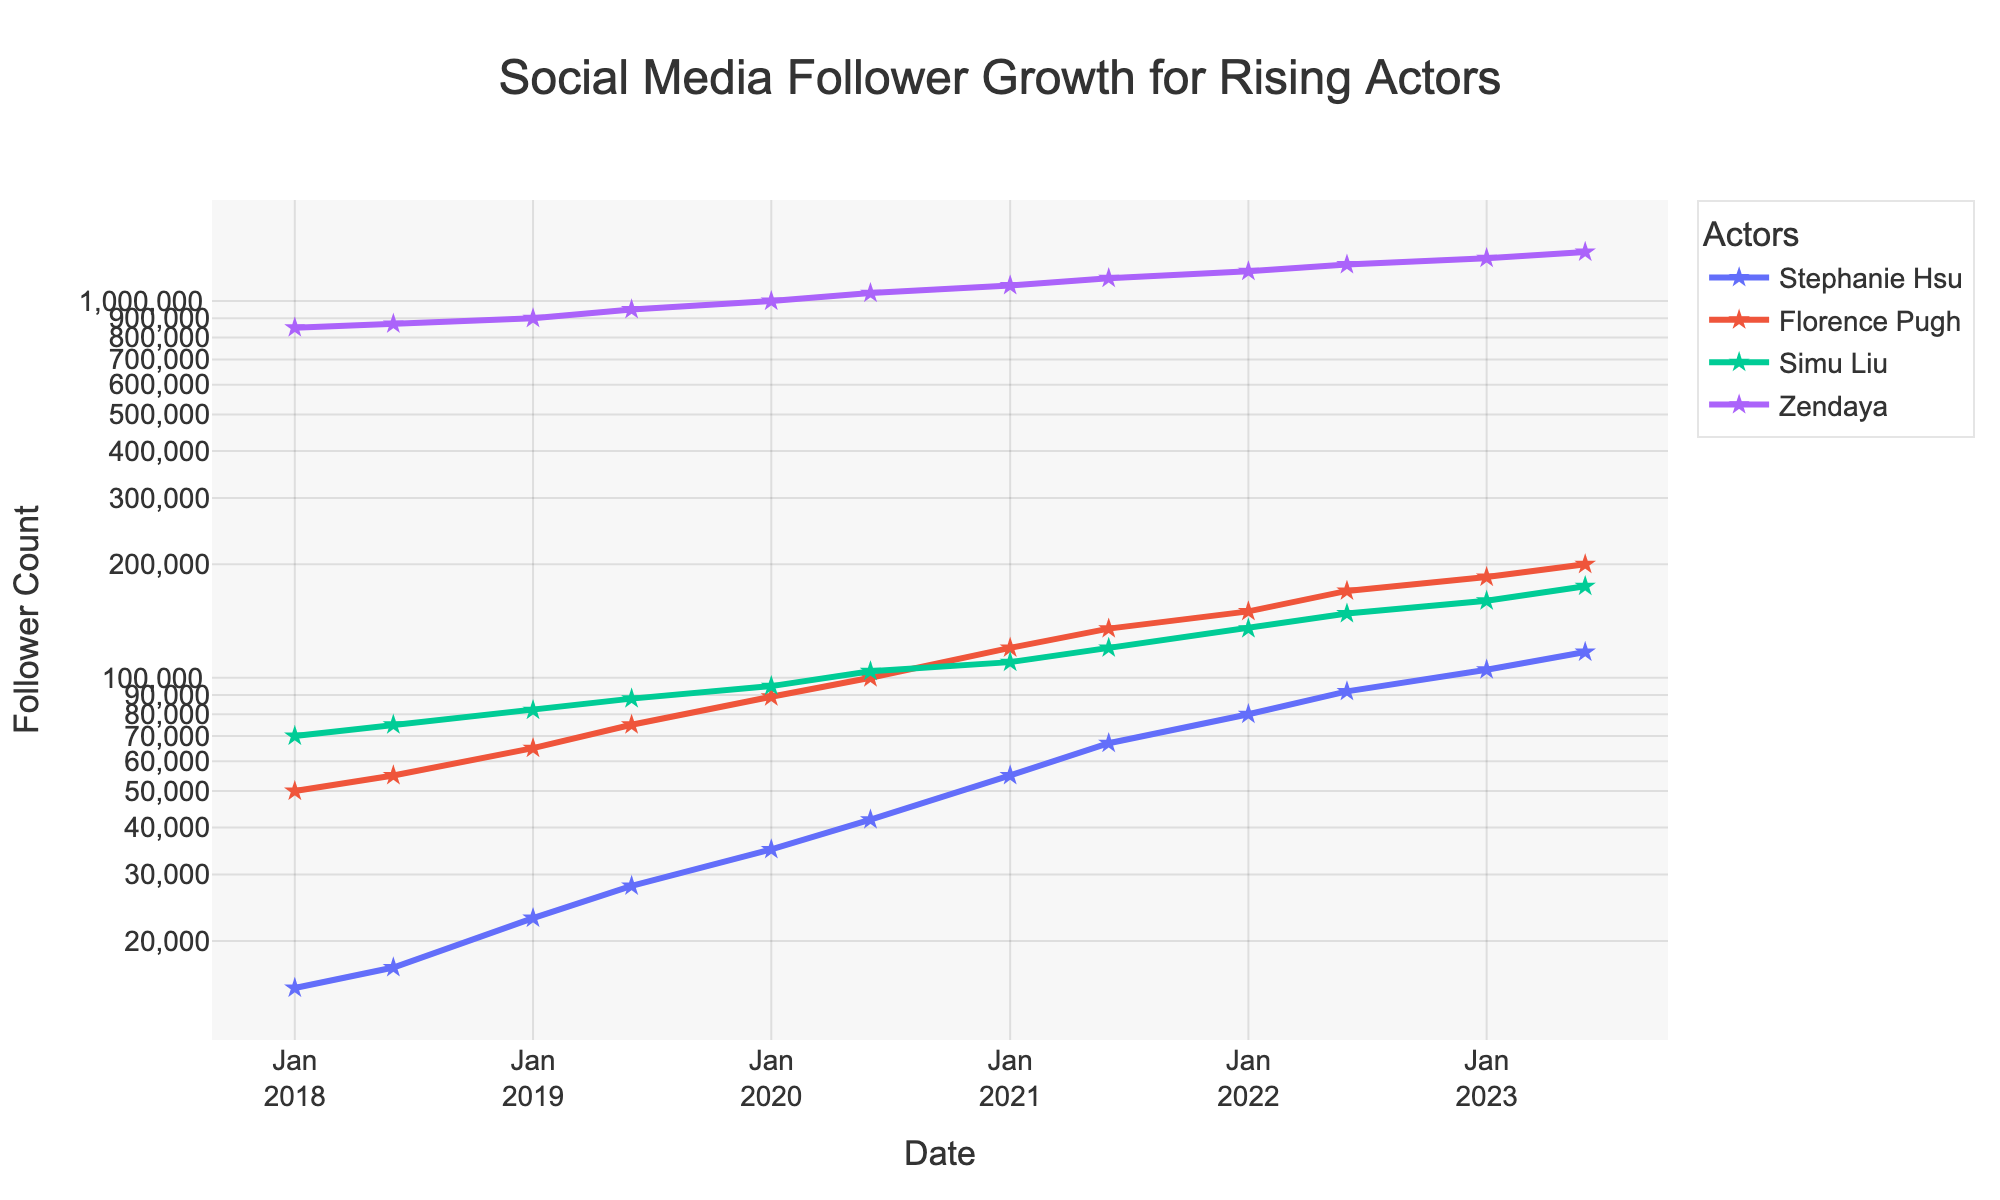Which actor has the highest follower count in Jan 2023? Look at the data points for January 2023 and compare the follower counts for all the actors. Zendaya has 1,300,000 followers which is the highest.
Answer: Zendaya Compare the follower growth of Stephanie Hsu and Simu Liu between January 2022 and January 2023. Who had a higher increase? For January 2022, Stephanie Hsu had 80,000 followers and in January 2023 she had 105,000, an increase of 25,000. Simu Liu had 135,000 followers in January 2022 and 160,000 in January 2023, an increase of 25,000. Both had the same increase.
Answer: Both had the same increase What is the trend in Zendaya’s engagement rate from 2020 to 2023? Look at the engagement rate of Zendaya at different timestamps from 2020 to 2023. The engagement rate starts from 11.5 in January 2020 and gradually increases to 13.2 by June 2023.
Answer: Increasing Based on visual inspection, during which period did Stephanie Hsu’s follower count experience the fastest growth? Look at the slope of the line representing Stephanie Hsu's follower count over the 5-year period. The steepest increase appears between 2020 and 2021.
Answer: Between 2020 and 2021 What is the average engagement rate for Florence Pugh in 2020? Consider the engagement rates for Florence Pugh in January 2020 (5.3) and June 2020 (5.5). The average is (5.3 + 5.5) / 2.
Answer: 5.4 Between June 2022 and June 2023, whose follower count grew faster: Florence Pugh or Simu Liu? Calculate the increase in follower count for both actors. Florence Pugh goes from 170,000 to 200,000 (increase of 30,000) and Simu Liu from 148,000 to 175,000 (increase of 27,000).
Answer: Florence Pugh Which actor had the most stable engagement rate over the 5-year period? Look at the fluctuations in the engagement rates over time for each actor. Florence Pugh's engagement rate shows the least fluctuation.
Answer: Florence Pugh What can you infer about the difference in social media popularity between actors on Instagram and TikTok based on follower counts? Compare the follower counts of actors using Instagram and TikTok. Zendaya on TikTok has much higher follower counts compared to actors on Instagram, indicating higher popularity.
Answer: TikTok (Zendaya) How did Simu Liu’s follower count change from January 2018 to June 2023, and what is the overall trend? Note the follower counts for Simu Liu at these two points: January 2018 (70,000) and June 2023 (175,000). The overall trend is increasing.
Answer: Increasing 